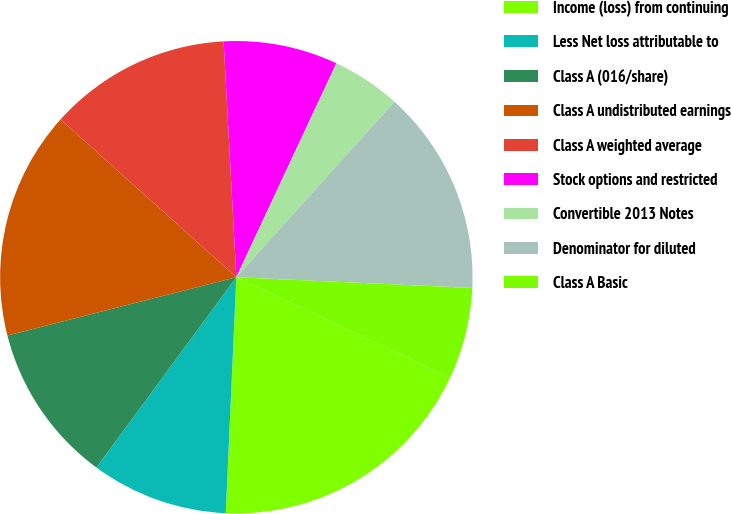Convert chart. <chart><loc_0><loc_0><loc_500><loc_500><pie_chart><fcel>Income (loss) from continuing<fcel>Less Net loss attributable to<fcel>Class A (016/share)<fcel>Class A undistributed earnings<fcel>Class A weighted average<fcel>Stock options and restricted<fcel>Convertible 2013 Notes<fcel>Denominator for diluted<fcel>Class A Basic<nl><fcel>18.72%<fcel>9.38%<fcel>10.94%<fcel>15.61%<fcel>12.5%<fcel>7.82%<fcel>4.71%<fcel>14.05%<fcel>6.27%<nl></chart> 